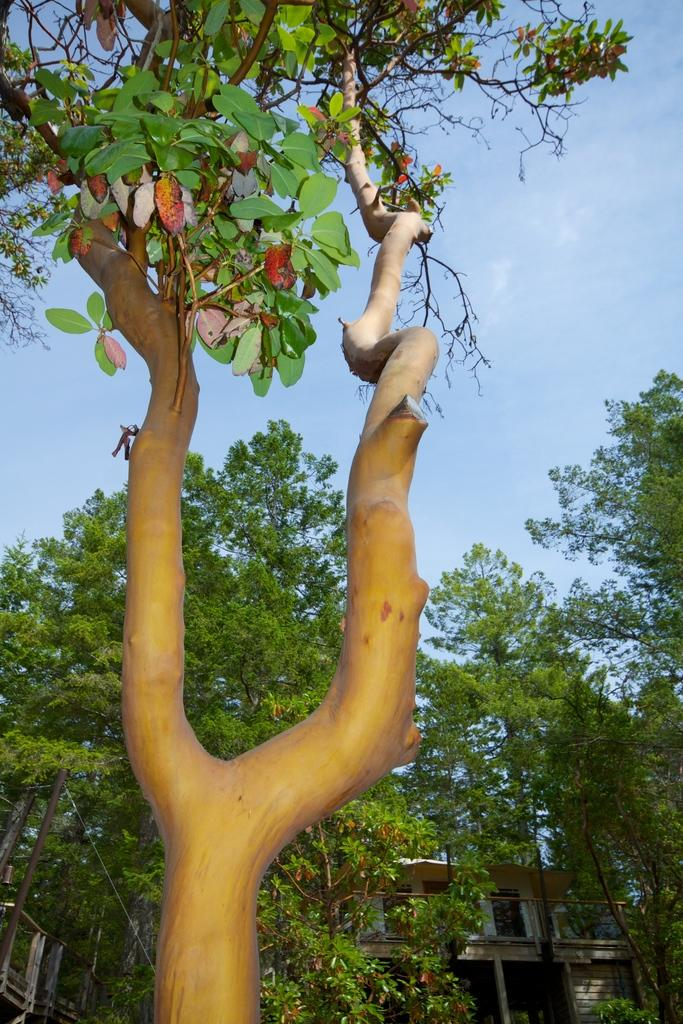What type of natural elements can be seen in the image? There are trees in the image. What type of man-made structures are visible in the image? There are buildings in the image. Can you describe the setting of the image? The image features a combination of natural elements (trees) and man-made structures (buildings). What type of sail can be seen on the liquid in the image? There is no sail or liquid present in the image; it features trees and buildings. 